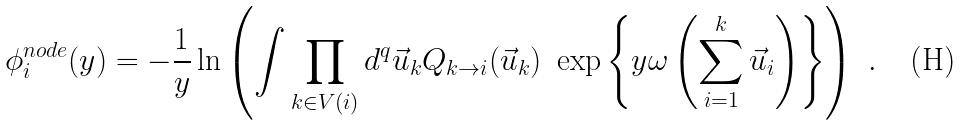<formula> <loc_0><loc_0><loc_500><loc_500>\phi _ { i } ^ { n o d e } ( y ) = - \frac { 1 } { y } \ln \left ( \int \prod _ { k \in V ( i ) } d ^ { q } \vec { u } _ { k } Q _ { k \to i } ( \vec { u } _ { k } ) \ \exp \left \{ y \omega \left ( \sum _ { i = 1 } ^ { k } \vec { u } _ { i } \right ) \right \} \right ) \ .</formula> 